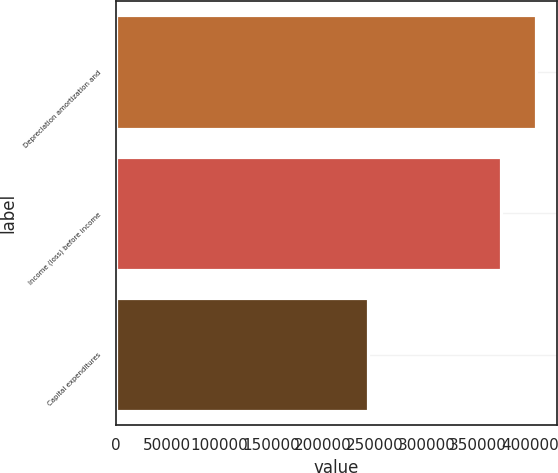<chart> <loc_0><loc_0><loc_500><loc_500><bar_chart><fcel>Depreciation amortization and<fcel>Income (loss) before income<fcel>Capital expenditures<nl><fcel>405332<fcel>371920<fcel>243484<nl></chart> 